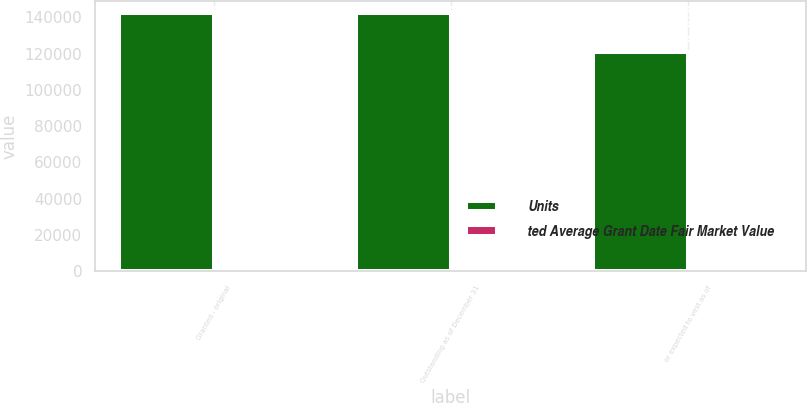Convert chart to OTSL. <chart><loc_0><loc_0><loc_500><loc_500><stacked_bar_chart><ecel><fcel>Granted - original<fcel>Outstanding as of December 31<fcel>or expected to vest as of<nl><fcel>Units<fcel>142217<fcel>142217<fcel>120884<nl><fcel>ted Average Grant Date Fair Market Value<fcel>195.98<fcel>195.98<fcel>195.98<nl></chart> 